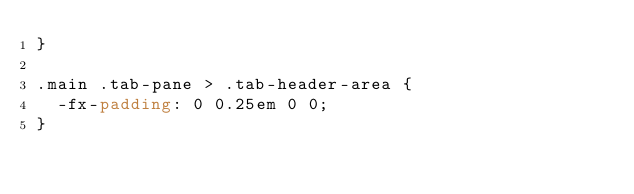Convert code to text. <code><loc_0><loc_0><loc_500><loc_500><_CSS_>}

.main .tab-pane > .tab-header-area {
	-fx-padding: 0 0.25em 0 0;
}
</code> 